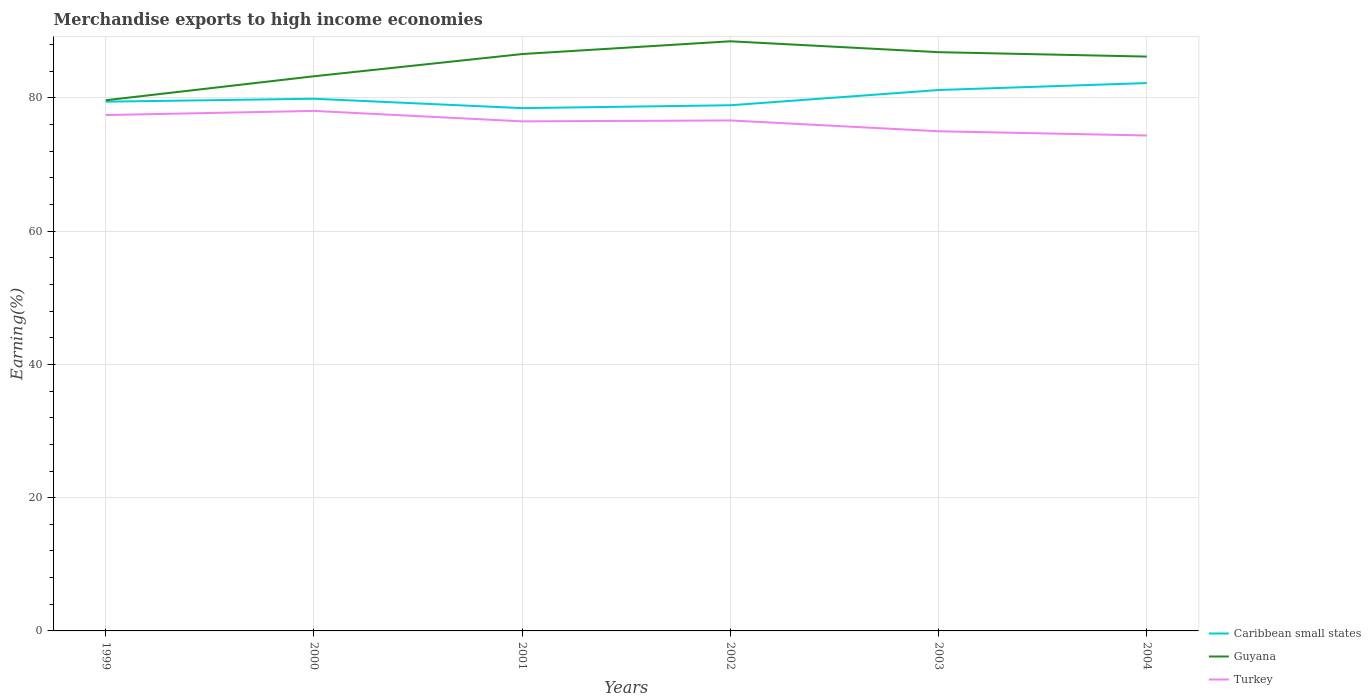How many different coloured lines are there?
Provide a short and direct response. 3. Across all years, what is the maximum percentage of amount earned from merchandise exports in Caribbean small states?
Offer a terse response. 78.46. What is the total percentage of amount earned from merchandise exports in Guyana in the graph?
Your answer should be very brief. 1.63. What is the difference between the highest and the second highest percentage of amount earned from merchandise exports in Turkey?
Offer a very short reply. 3.69. What is the difference between the highest and the lowest percentage of amount earned from merchandise exports in Caribbean small states?
Ensure brevity in your answer.  2. Is the percentage of amount earned from merchandise exports in Caribbean small states strictly greater than the percentage of amount earned from merchandise exports in Turkey over the years?
Your answer should be compact. No. How many years are there in the graph?
Ensure brevity in your answer.  6. What is the difference between two consecutive major ticks on the Y-axis?
Ensure brevity in your answer.  20. Are the values on the major ticks of Y-axis written in scientific E-notation?
Make the answer very short. No. Where does the legend appear in the graph?
Your answer should be compact. Bottom right. How many legend labels are there?
Keep it short and to the point. 3. What is the title of the graph?
Your answer should be very brief. Merchandise exports to high income economies. Does "Papua New Guinea" appear as one of the legend labels in the graph?
Keep it short and to the point. No. What is the label or title of the X-axis?
Your response must be concise. Years. What is the label or title of the Y-axis?
Offer a terse response. Earning(%). What is the Earning(%) of Caribbean small states in 1999?
Make the answer very short. 79.43. What is the Earning(%) of Guyana in 1999?
Offer a very short reply. 79.64. What is the Earning(%) of Turkey in 1999?
Your answer should be compact. 77.42. What is the Earning(%) of Caribbean small states in 2000?
Offer a very short reply. 79.86. What is the Earning(%) of Guyana in 2000?
Give a very brief answer. 83.24. What is the Earning(%) in Turkey in 2000?
Your answer should be very brief. 78.04. What is the Earning(%) of Caribbean small states in 2001?
Make the answer very short. 78.46. What is the Earning(%) in Guyana in 2001?
Offer a very short reply. 86.57. What is the Earning(%) of Turkey in 2001?
Provide a short and direct response. 76.47. What is the Earning(%) in Caribbean small states in 2002?
Offer a terse response. 78.89. What is the Earning(%) in Guyana in 2002?
Provide a succinct answer. 88.49. What is the Earning(%) in Turkey in 2002?
Your response must be concise. 76.61. What is the Earning(%) in Caribbean small states in 2003?
Make the answer very short. 81.18. What is the Earning(%) in Guyana in 2003?
Your response must be concise. 86.86. What is the Earning(%) in Turkey in 2003?
Your answer should be very brief. 74.99. What is the Earning(%) of Caribbean small states in 2004?
Your answer should be compact. 82.22. What is the Earning(%) of Guyana in 2004?
Your answer should be very brief. 86.19. What is the Earning(%) in Turkey in 2004?
Give a very brief answer. 74.35. Across all years, what is the maximum Earning(%) in Caribbean small states?
Offer a very short reply. 82.22. Across all years, what is the maximum Earning(%) in Guyana?
Provide a succinct answer. 88.49. Across all years, what is the maximum Earning(%) in Turkey?
Offer a very short reply. 78.04. Across all years, what is the minimum Earning(%) in Caribbean small states?
Your answer should be very brief. 78.46. Across all years, what is the minimum Earning(%) in Guyana?
Offer a terse response. 79.64. Across all years, what is the minimum Earning(%) in Turkey?
Your answer should be compact. 74.35. What is the total Earning(%) in Caribbean small states in the graph?
Your answer should be very brief. 480.03. What is the total Earning(%) in Guyana in the graph?
Offer a terse response. 510.99. What is the total Earning(%) of Turkey in the graph?
Provide a succinct answer. 457.88. What is the difference between the Earning(%) of Caribbean small states in 1999 and that in 2000?
Offer a very short reply. -0.44. What is the difference between the Earning(%) in Guyana in 1999 and that in 2000?
Give a very brief answer. -3.6. What is the difference between the Earning(%) in Turkey in 1999 and that in 2000?
Offer a terse response. -0.62. What is the difference between the Earning(%) in Caribbean small states in 1999 and that in 2001?
Give a very brief answer. 0.97. What is the difference between the Earning(%) in Guyana in 1999 and that in 2001?
Make the answer very short. -6.93. What is the difference between the Earning(%) in Turkey in 1999 and that in 2001?
Give a very brief answer. 0.94. What is the difference between the Earning(%) in Caribbean small states in 1999 and that in 2002?
Your answer should be compact. 0.54. What is the difference between the Earning(%) of Guyana in 1999 and that in 2002?
Provide a short and direct response. -8.85. What is the difference between the Earning(%) of Turkey in 1999 and that in 2002?
Ensure brevity in your answer.  0.81. What is the difference between the Earning(%) of Caribbean small states in 1999 and that in 2003?
Make the answer very short. -1.75. What is the difference between the Earning(%) in Guyana in 1999 and that in 2003?
Make the answer very short. -7.22. What is the difference between the Earning(%) of Turkey in 1999 and that in 2003?
Your answer should be very brief. 2.43. What is the difference between the Earning(%) in Caribbean small states in 1999 and that in 2004?
Your answer should be compact. -2.79. What is the difference between the Earning(%) of Guyana in 1999 and that in 2004?
Offer a terse response. -6.55. What is the difference between the Earning(%) of Turkey in 1999 and that in 2004?
Make the answer very short. 3.06. What is the difference between the Earning(%) in Caribbean small states in 2000 and that in 2001?
Provide a succinct answer. 1.41. What is the difference between the Earning(%) in Guyana in 2000 and that in 2001?
Your response must be concise. -3.33. What is the difference between the Earning(%) of Turkey in 2000 and that in 2001?
Offer a very short reply. 1.57. What is the difference between the Earning(%) of Caribbean small states in 2000 and that in 2002?
Your response must be concise. 0.98. What is the difference between the Earning(%) in Guyana in 2000 and that in 2002?
Your answer should be very brief. -5.25. What is the difference between the Earning(%) in Turkey in 2000 and that in 2002?
Make the answer very short. 1.43. What is the difference between the Earning(%) of Caribbean small states in 2000 and that in 2003?
Offer a terse response. -1.31. What is the difference between the Earning(%) in Guyana in 2000 and that in 2003?
Keep it short and to the point. -3.62. What is the difference between the Earning(%) of Turkey in 2000 and that in 2003?
Offer a terse response. 3.05. What is the difference between the Earning(%) in Caribbean small states in 2000 and that in 2004?
Your response must be concise. -2.35. What is the difference between the Earning(%) of Guyana in 2000 and that in 2004?
Give a very brief answer. -2.95. What is the difference between the Earning(%) of Turkey in 2000 and that in 2004?
Give a very brief answer. 3.69. What is the difference between the Earning(%) of Caribbean small states in 2001 and that in 2002?
Provide a succinct answer. -0.43. What is the difference between the Earning(%) of Guyana in 2001 and that in 2002?
Keep it short and to the point. -1.92. What is the difference between the Earning(%) of Turkey in 2001 and that in 2002?
Offer a very short reply. -0.14. What is the difference between the Earning(%) in Caribbean small states in 2001 and that in 2003?
Your answer should be compact. -2.72. What is the difference between the Earning(%) in Guyana in 2001 and that in 2003?
Provide a short and direct response. -0.28. What is the difference between the Earning(%) in Turkey in 2001 and that in 2003?
Provide a short and direct response. 1.49. What is the difference between the Earning(%) of Caribbean small states in 2001 and that in 2004?
Ensure brevity in your answer.  -3.76. What is the difference between the Earning(%) in Guyana in 2001 and that in 2004?
Give a very brief answer. 0.38. What is the difference between the Earning(%) in Turkey in 2001 and that in 2004?
Make the answer very short. 2.12. What is the difference between the Earning(%) of Caribbean small states in 2002 and that in 2003?
Offer a very short reply. -2.29. What is the difference between the Earning(%) in Guyana in 2002 and that in 2003?
Provide a short and direct response. 1.63. What is the difference between the Earning(%) in Turkey in 2002 and that in 2003?
Offer a terse response. 1.63. What is the difference between the Earning(%) in Caribbean small states in 2002 and that in 2004?
Offer a very short reply. -3.33. What is the difference between the Earning(%) in Guyana in 2002 and that in 2004?
Ensure brevity in your answer.  2.3. What is the difference between the Earning(%) of Turkey in 2002 and that in 2004?
Your response must be concise. 2.26. What is the difference between the Earning(%) in Caribbean small states in 2003 and that in 2004?
Provide a short and direct response. -1.04. What is the difference between the Earning(%) of Guyana in 2003 and that in 2004?
Keep it short and to the point. 0.66. What is the difference between the Earning(%) of Turkey in 2003 and that in 2004?
Give a very brief answer. 0.63. What is the difference between the Earning(%) in Caribbean small states in 1999 and the Earning(%) in Guyana in 2000?
Provide a short and direct response. -3.81. What is the difference between the Earning(%) in Caribbean small states in 1999 and the Earning(%) in Turkey in 2000?
Provide a short and direct response. 1.39. What is the difference between the Earning(%) in Caribbean small states in 1999 and the Earning(%) in Guyana in 2001?
Make the answer very short. -7.15. What is the difference between the Earning(%) in Caribbean small states in 1999 and the Earning(%) in Turkey in 2001?
Offer a terse response. 2.95. What is the difference between the Earning(%) in Guyana in 1999 and the Earning(%) in Turkey in 2001?
Offer a terse response. 3.17. What is the difference between the Earning(%) of Caribbean small states in 1999 and the Earning(%) of Guyana in 2002?
Offer a terse response. -9.06. What is the difference between the Earning(%) of Caribbean small states in 1999 and the Earning(%) of Turkey in 2002?
Keep it short and to the point. 2.82. What is the difference between the Earning(%) of Guyana in 1999 and the Earning(%) of Turkey in 2002?
Provide a succinct answer. 3.03. What is the difference between the Earning(%) in Caribbean small states in 1999 and the Earning(%) in Guyana in 2003?
Your response must be concise. -7.43. What is the difference between the Earning(%) of Caribbean small states in 1999 and the Earning(%) of Turkey in 2003?
Your answer should be compact. 4.44. What is the difference between the Earning(%) of Guyana in 1999 and the Earning(%) of Turkey in 2003?
Your answer should be compact. 4.65. What is the difference between the Earning(%) in Caribbean small states in 1999 and the Earning(%) in Guyana in 2004?
Give a very brief answer. -6.77. What is the difference between the Earning(%) of Caribbean small states in 1999 and the Earning(%) of Turkey in 2004?
Give a very brief answer. 5.07. What is the difference between the Earning(%) of Guyana in 1999 and the Earning(%) of Turkey in 2004?
Give a very brief answer. 5.29. What is the difference between the Earning(%) in Caribbean small states in 2000 and the Earning(%) in Guyana in 2001?
Provide a short and direct response. -6.71. What is the difference between the Earning(%) in Caribbean small states in 2000 and the Earning(%) in Turkey in 2001?
Keep it short and to the point. 3.39. What is the difference between the Earning(%) of Guyana in 2000 and the Earning(%) of Turkey in 2001?
Your answer should be very brief. 6.77. What is the difference between the Earning(%) of Caribbean small states in 2000 and the Earning(%) of Guyana in 2002?
Provide a short and direct response. -8.62. What is the difference between the Earning(%) in Caribbean small states in 2000 and the Earning(%) in Turkey in 2002?
Give a very brief answer. 3.25. What is the difference between the Earning(%) in Guyana in 2000 and the Earning(%) in Turkey in 2002?
Offer a very short reply. 6.63. What is the difference between the Earning(%) of Caribbean small states in 2000 and the Earning(%) of Guyana in 2003?
Provide a succinct answer. -6.99. What is the difference between the Earning(%) in Caribbean small states in 2000 and the Earning(%) in Turkey in 2003?
Ensure brevity in your answer.  4.88. What is the difference between the Earning(%) of Guyana in 2000 and the Earning(%) of Turkey in 2003?
Make the answer very short. 8.25. What is the difference between the Earning(%) in Caribbean small states in 2000 and the Earning(%) in Guyana in 2004?
Give a very brief answer. -6.33. What is the difference between the Earning(%) in Caribbean small states in 2000 and the Earning(%) in Turkey in 2004?
Keep it short and to the point. 5.51. What is the difference between the Earning(%) in Guyana in 2000 and the Earning(%) in Turkey in 2004?
Your response must be concise. 8.89. What is the difference between the Earning(%) in Caribbean small states in 2001 and the Earning(%) in Guyana in 2002?
Offer a terse response. -10.03. What is the difference between the Earning(%) of Caribbean small states in 2001 and the Earning(%) of Turkey in 2002?
Keep it short and to the point. 1.85. What is the difference between the Earning(%) in Guyana in 2001 and the Earning(%) in Turkey in 2002?
Ensure brevity in your answer.  9.96. What is the difference between the Earning(%) of Caribbean small states in 2001 and the Earning(%) of Guyana in 2003?
Make the answer very short. -8.4. What is the difference between the Earning(%) in Caribbean small states in 2001 and the Earning(%) in Turkey in 2003?
Ensure brevity in your answer.  3.47. What is the difference between the Earning(%) in Guyana in 2001 and the Earning(%) in Turkey in 2003?
Offer a very short reply. 11.59. What is the difference between the Earning(%) of Caribbean small states in 2001 and the Earning(%) of Guyana in 2004?
Keep it short and to the point. -7.74. What is the difference between the Earning(%) in Caribbean small states in 2001 and the Earning(%) in Turkey in 2004?
Offer a terse response. 4.11. What is the difference between the Earning(%) of Guyana in 2001 and the Earning(%) of Turkey in 2004?
Give a very brief answer. 12.22. What is the difference between the Earning(%) in Caribbean small states in 2002 and the Earning(%) in Guyana in 2003?
Offer a terse response. -7.97. What is the difference between the Earning(%) in Caribbean small states in 2002 and the Earning(%) in Turkey in 2003?
Offer a terse response. 3.9. What is the difference between the Earning(%) in Guyana in 2002 and the Earning(%) in Turkey in 2003?
Provide a short and direct response. 13.5. What is the difference between the Earning(%) of Caribbean small states in 2002 and the Earning(%) of Guyana in 2004?
Ensure brevity in your answer.  -7.3. What is the difference between the Earning(%) of Caribbean small states in 2002 and the Earning(%) of Turkey in 2004?
Offer a terse response. 4.54. What is the difference between the Earning(%) in Guyana in 2002 and the Earning(%) in Turkey in 2004?
Give a very brief answer. 14.14. What is the difference between the Earning(%) in Caribbean small states in 2003 and the Earning(%) in Guyana in 2004?
Make the answer very short. -5.02. What is the difference between the Earning(%) in Caribbean small states in 2003 and the Earning(%) in Turkey in 2004?
Make the answer very short. 6.82. What is the difference between the Earning(%) of Guyana in 2003 and the Earning(%) of Turkey in 2004?
Offer a terse response. 12.5. What is the average Earning(%) in Caribbean small states per year?
Provide a succinct answer. 80.01. What is the average Earning(%) in Guyana per year?
Your response must be concise. 85.17. What is the average Earning(%) in Turkey per year?
Offer a very short reply. 76.31. In the year 1999, what is the difference between the Earning(%) of Caribbean small states and Earning(%) of Guyana?
Your response must be concise. -0.21. In the year 1999, what is the difference between the Earning(%) in Caribbean small states and Earning(%) in Turkey?
Your answer should be compact. 2.01. In the year 1999, what is the difference between the Earning(%) in Guyana and Earning(%) in Turkey?
Your answer should be very brief. 2.22. In the year 2000, what is the difference between the Earning(%) of Caribbean small states and Earning(%) of Guyana?
Offer a very short reply. -3.37. In the year 2000, what is the difference between the Earning(%) in Caribbean small states and Earning(%) in Turkey?
Your answer should be compact. 1.82. In the year 2000, what is the difference between the Earning(%) of Guyana and Earning(%) of Turkey?
Your answer should be very brief. 5.2. In the year 2001, what is the difference between the Earning(%) of Caribbean small states and Earning(%) of Guyana?
Provide a short and direct response. -8.12. In the year 2001, what is the difference between the Earning(%) in Caribbean small states and Earning(%) in Turkey?
Provide a succinct answer. 1.98. In the year 2001, what is the difference between the Earning(%) in Guyana and Earning(%) in Turkey?
Your answer should be very brief. 10.1. In the year 2002, what is the difference between the Earning(%) in Caribbean small states and Earning(%) in Guyana?
Make the answer very short. -9.6. In the year 2002, what is the difference between the Earning(%) in Caribbean small states and Earning(%) in Turkey?
Your response must be concise. 2.28. In the year 2002, what is the difference between the Earning(%) in Guyana and Earning(%) in Turkey?
Keep it short and to the point. 11.88. In the year 2003, what is the difference between the Earning(%) in Caribbean small states and Earning(%) in Guyana?
Offer a very short reply. -5.68. In the year 2003, what is the difference between the Earning(%) in Caribbean small states and Earning(%) in Turkey?
Your response must be concise. 6.19. In the year 2003, what is the difference between the Earning(%) in Guyana and Earning(%) in Turkey?
Keep it short and to the point. 11.87. In the year 2004, what is the difference between the Earning(%) of Caribbean small states and Earning(%) of Guyana?
Offer a very short reply. -3.97. In the year 2004, what is the difference between the Earning(%) of Caribbean small states and Earning(%) of Turkey?
Offer a very short reply. 7.87. In the year 2004, what is the difference between the Earning(%) in Guyana and Earning(%) in Turkey?
Offer a very short reply. 11.84. What is the ratio of the Earning(%) of Guyana in 1999 to that in 2000?
Offer a terse response. 0.96. What is the ratio of the Earning(%) in Turkey in 1999 to that in 2000?
Provide a short and direct response. 0.99. What is the ratio of the Earning(%) of Caribbean small states in 1999 to that in 2001?
Provide a short and direct response. 1.01. What is the ratio of the Earning(%) in Guyana in 1999 to that in 2001?
Offer a terse response. 0.92. What is the ratio of the Earning(%) of Turkey in 1999 to that in 2001?
Provide a succinct answer. 1.01. What is the ratio of the Earning(%) in Caribbean small states in 1999 to that in 2002?
Give a very brief answer. 1.01. What is the ratio of the Earning(%) in Turkey in 1999 to that in 2002?
Ensure brevity in your answer.  1.01. What is the ratio of the Earning(%) of Caribbean small states in 1999 to that in 2003?
Keep it short and to the point. 0.98. What is the ratio of the Earning(%) of Guyana in 1999 to that in 2003?
Offer a very short reply. 0.92. What is the ratio of the Earning(%) of Turkey in 1999 to that in 2003?
Give a very brief answer. 1.03. What is the ratio of the Earning(%) of Caribbean small states in 1999 to that in 2004?
Provide a succinct answer. 0.97. What is the ratio of the Earning(%) of Guyana in 1999 to that in 2004?
Ensure brevity in your answer.  0.92. What is the ratio of the Earning(%) of Turkey in 1999 to that in 2004?
Your answer should be compact. 1.04. What is the ratio of the Earning(%) in Caribbean small states in 2000 to that in 2001?
Your response must be concise. 1.02. What is the ratio of the Earning(%) of Guyana in 2000 to that in 2001?
Your answer should be compact. 0.96. What is the ratio of the Earning(%) of Turkey in 2000 to that in 2001?
Your answer should be very brief. 1.02. What is the ratio of the Earning(%) of Caribbean small states in 2000 to that in 2002?
Make the answer very short. 1.01. What is the ratio of the Earning(%) of Guyana in 2000 to that in 2002?
Offer a very short reply. 0.94. What is the ratio of the Earning(%) in Turkey in 2000 to that in 2002?
Ensure brevity in your answer.  1.02. What is the ratio of the Earning(%) in Caribbean small states in 2000 to that in 2003?
Offer a very short reply. 0.98. What is the ratio of the Earning(%) in Guyana in 2000 to that in 2003?
Keep it short and to the point. 0.96. What is the ratio of the Earning(%) in Turkey in 2000 to that in 2003?
Provide a succinct answer. 1.04. What is the ratio of the Earning(%) of Caribbean small states in 2000 to that in 2004?
Keep it short and to the point. 0.97. What is the ratio of the Earning(%) in Guyana in 2000 to that in 2004?
Offer a terse response. 0.97. What is the ratio of the Earning(%) in Turkey in 2000 to that in 2004?
Give a very brief answer. 1.05. What is the ratio of the Earning(%) of Guyana in 2001 to that in 2002?
Ensure brevity in your answer.  0.98. What is the ratio of the Earning(%) of Turkey in 2001 to that in 2002?
Provide a short and direct response. 1. What is the ratio of the Earning(%) in Caribbean small states in 2001 to that in 2003?
Provide a succinct answer. 0.97. What is the ratio of the Earning(%) of Guyana in 2001 to that in 2003?
Ensure brevity in your answer.  1. What is the ratio of the Earning(%) of Turkey in 2001 to that in 2003?
Offer a terse response. 1.02. What is the ratio of the Earning(%) in Caribbean small states in 2001 to that in 2004?
Keep it short and to the point. 0.95. What is the ratio of the Earning(%) in Guyana in 2001 to that in 2004?
Keep it short and to the point. 1. What is the ratio of the Earning(%) of Turkey in 2001 to that in 2004?
Provide a short and direct response. 1.03. What is the ratio of the Earning(%) of Caribbean small states in 2002 to that in 2003?
Your answer should be very brief. 0.97. What is the ratio of the Earning(%) in Guyana in 2002 to that in 2003?
Offer a very short reply. 1.02. What is the ratio of the Earning(%) of Turkey in 2002 to that in 2003?
Offer a terse response. 1.02. What is the ratio of the Earning(%) of Caribbean small states in 2002 to that in 2004?
Your answer should be compact. 0.96. What is the ratio of the Earning(%) in Guyana in 2002 to that in 2004?
Provide a short and direct response. 1.03. What is the ratio of the Earning(%) of Turkey in 2002 to that in 2004?
Offer a terse response. 1.03. What is the ratio of the Earning(%) of Caribbean small states in 2003 to that in 2004?
Your answer should be compact. 0.99. What is the ratio of the Earning(%) of Guyana in 2003 to that in 2004?
Provide a succinct answer. 1.01. What is the ratio of the Earning(%) of Turkey in 2003 to that in 2004?
Ensure brevity in your answer.  1.01. What is the difference between the highest and the second highest Earning(%) in Caribbean small states?
Your answer should be very brief. 1.04. What is the difference between the highest and the second highest Earning(%) in Guyana?
Make the answer very short. 1.63. What is the difference between the highest and the second highest Earning(%) in Turkey?
Your response must be concise. 0.62. What is the difference between the highest and the lowest Earning(%) of Caribbean small states?
Your answer should be very brief. 3.76. What is the difference between the highest and the lowest Earning(%) in Guyana?
Make the answer very short. 8.85. What is the difference between the highest and the lowest Earning(%) of Turkey?
Give a very brief answer. 3.69. 